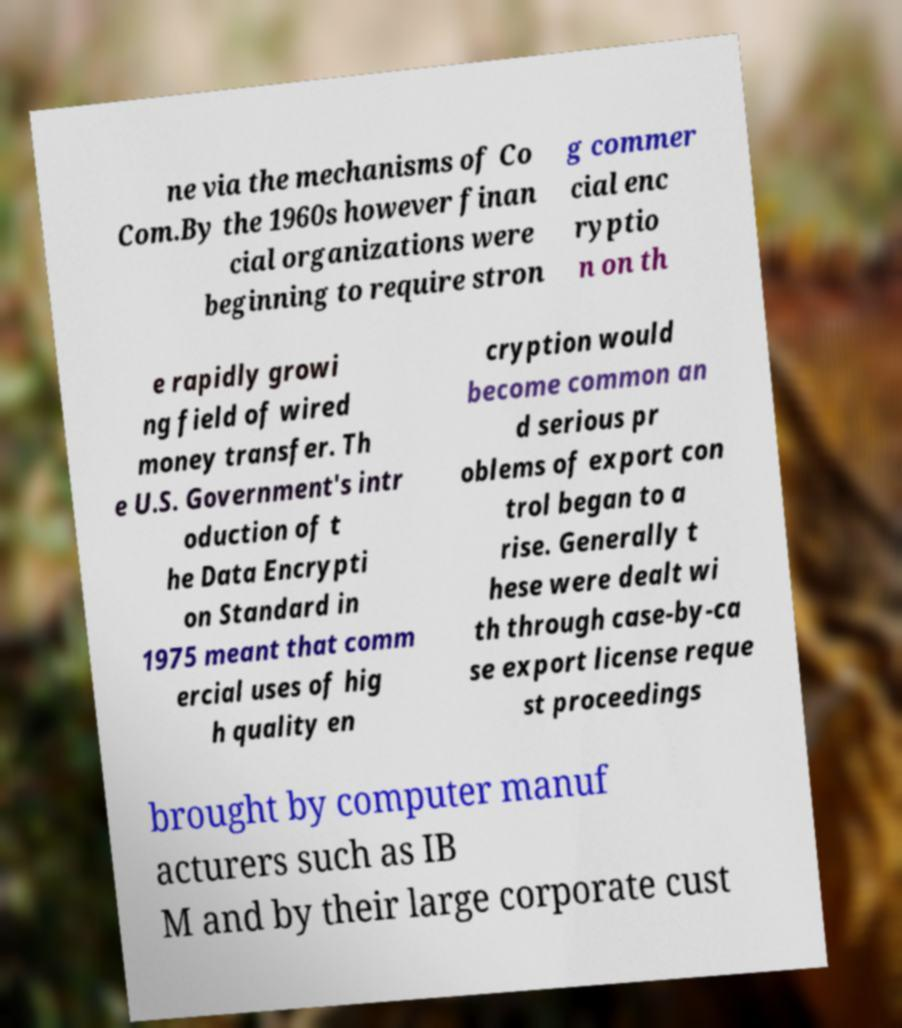Could you extract and type out the text from this image? ne via the mechanisms of Co Com.By the 1960s however finan cial organizations were beginning to require stron g commer cial enc ryptio n on th e rapidly growi ng field of wired money transfer. Th e U.S. Government's intr oduction of t he Data Encrypti on Standard in 1975 meant that comm ercial uses of hig h quality en cryption would become common an d serious pr oblems of export con trol began to a rise. Generally t hese were dealt wi th through case-by-ca se export license reque st proceedings brought by computer manuf acturers such as IB M and by their large corporate cust 